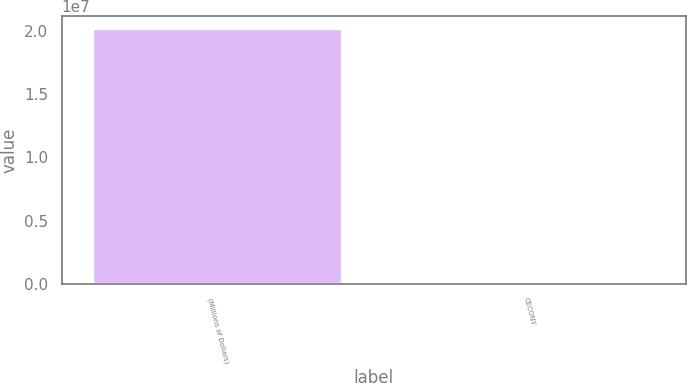Convert chart to OTSL. <chart><loc_0><loc_0><loc_500><loc_500><bar_chart><fcel>(Millions of Dollars)<fcel>CECONY<nl><fcel>2.0192e+07<fcel>3280<nl></chart> 